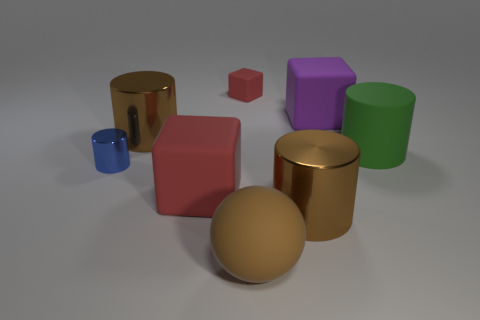What number of other things are there of the same color as the big sphere?
Offer a very short reply. 2. What is the shape of the big brown object that is made of the same material as the green thing?
Give a very brief answer. Sphere. Is there anything else that is the same shape as the big brown matte object?
Your answer should be very brief. No. The big matte cube on the right side of the red block that is in front of the cylinder that is behind the big green cylinder is what color?
Your answer should be very brief. Purple. Are there fewer large brown cylinders right of the big red rubber object than large cylinders that are behind the big brown sphere?
Ensure brevity in your answer.  Yes. Is the shape of the tiny blue object the same as the big green thing?
Your answer should be compact. Yes. What number of purple rubber objects have the same size as the brown sphere?
Keep it short and to the point. 1. Are there fewer large red things right of the tiny rubber cube than tiny red rubber cubes?
Provide a succinct answer. Yes. There is a shiny object that is on the right side of the brown metallic cylinder that is left of the brown matte ball; what size is it?
Provide a short and direct response. Large. How many things are tiny cubes or purple objects?
Keep it short and to the point. 2. 